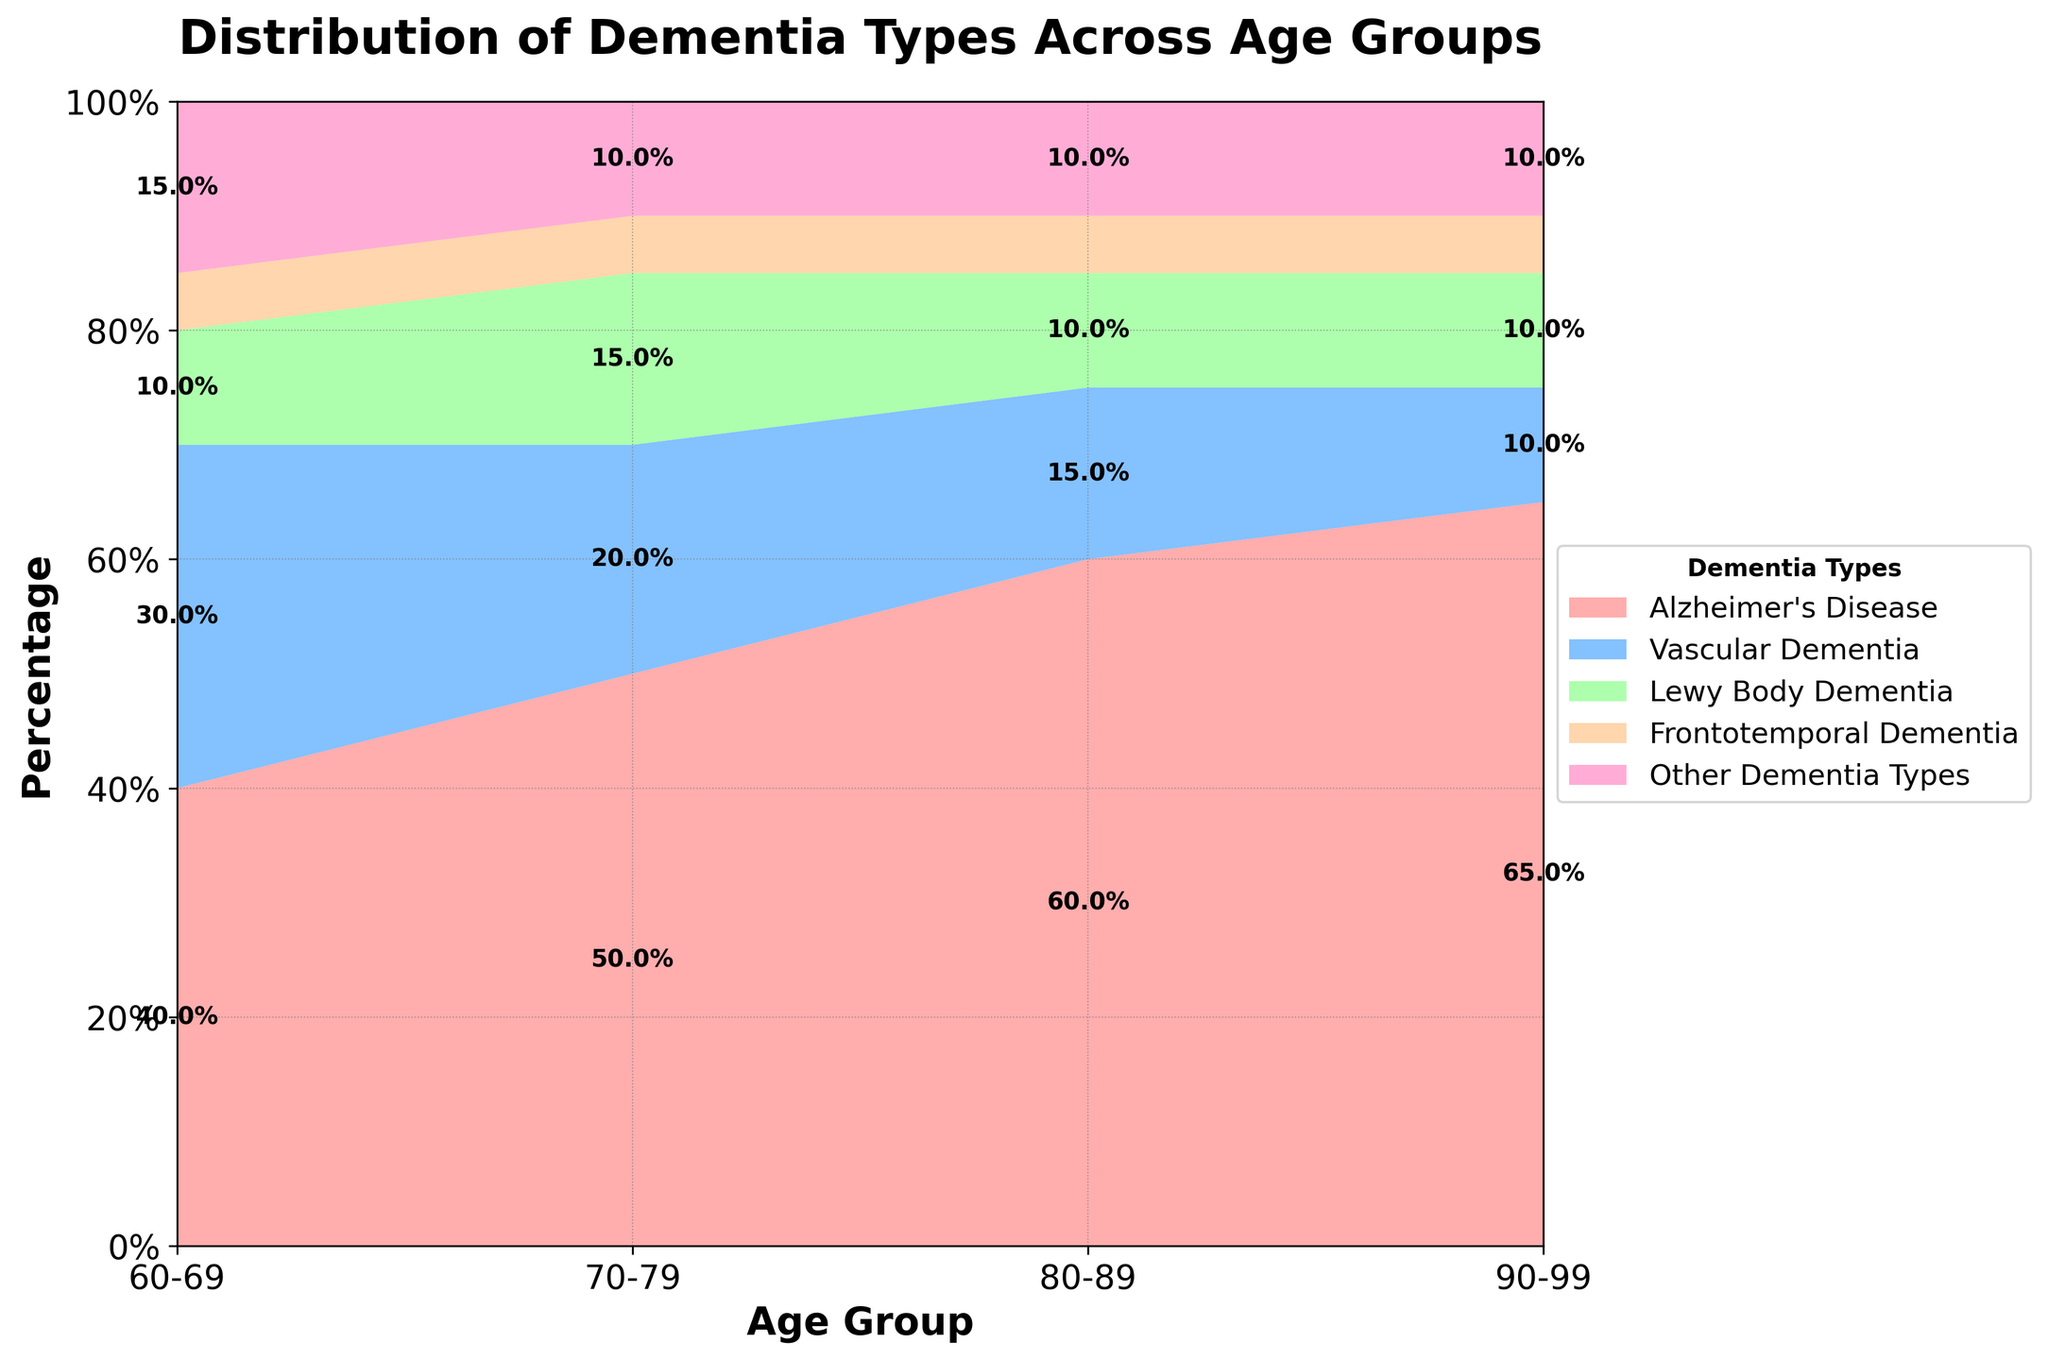What is the title of the figure? The title is usually displayed at the top of the figure. In this case, it is "Distribution of Dementia Types Across Age Groups".
Answer: Distribution of Dementia Types Across Age Groups Which age group has the highest percentage of Alzheimer's Disease? By looking at the areas representing Alzheimer's Disease, the largest one is over the age group 90-99.
Answer: 90-99 What is the percentage of Vascular Dementia in the 80-89 age group? The percentage for each dementia type is labeled on the figure. For Vascular Dementia in the 80-89 age group, it is 15%.
Answer: 15% Compare the proportion of Lewy Body Dementia between the age groups 60-69 and 70-79. In the 60-69 age group, the proportion for Lewy Body Dementia is 10%, whereas in the 70-79 age group, it is 15%.
Answer: 10%, 15% Which age group has the smallest percentage of Frontotemporal Dementia, and what is the percentage? The percentage for each age group can be defined by the smallest area representing Frontotemporal Dementia. For all age groups, it remains constant at 5%, which can be checked from the labels.
Answer: All age groups, 5% Among the age groups, which shows the smallest overall variety of dementia types? By inspecting the proportions visually, we see that the 90-99 age group has the smallest variation, with Alzheimer's taking a dominant share and fewer other dementia types shown.
Answer: 90-99 How does the percentage of Other Dementia Types vary between the age groups 70-79 and 90-99? The percentage of Other Dementia Types in both the 70-79 and 90-99 age groups is equal at 10%.
Answer: Same, 10% What is the total percentage of Alzheimer's Disease in the age groups 60-69 and 80-89 combined? Add the percentages of Alzheimer's Disease for both age groups: 40% (60-69) + 60% (80-89).
Answer: 100% Which dementia type shows the most consistent percentage distribution across all age groups? The percentages for Frontotemporal Dementia are consistently at 5% across all age groups according to the figure.
Answer: Frontotemporal Dementia In the age group 80-89, which dementia type has the second highest percentage, and what is it? From the figure, the second highest percentage for the 80-89 age group is Alzheimer's with 60%, making Vascular Dementia the second highest at 15%.
Answer: Vascular Dementia, 15% 